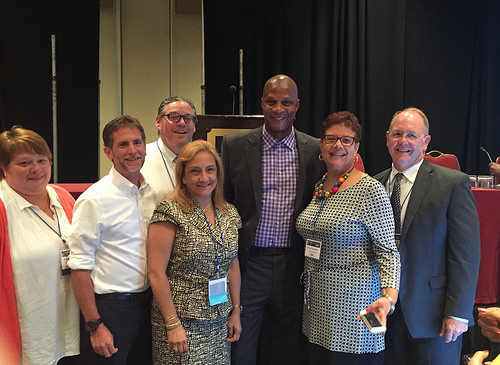<image>
Is there a lady on the man? No. The lady is not positioned on the man. They may be near each other, but the lady is not supported by or resting on top of the man. Where is the woman in relation to the man? Is it to the left of the man? No. The woman is not to the left of the man. From this viewpoint, they have a different horizontal relationship. 